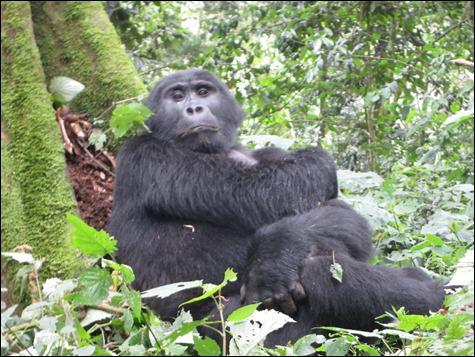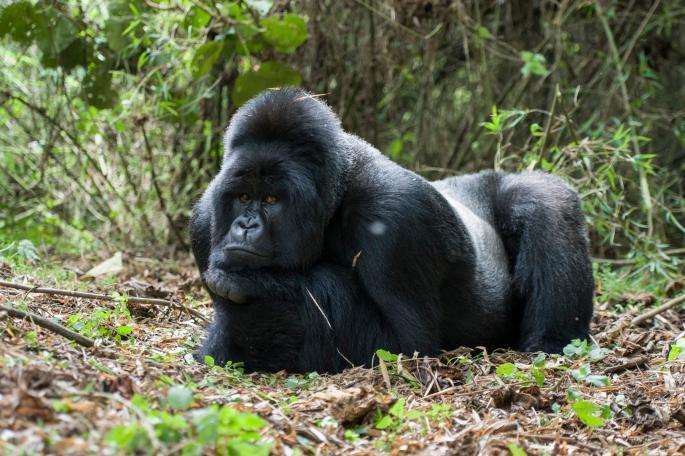The first image is the image on the left, the second image is the image on the right. Considering the images on both sides, is "One image shows a forward-gazing gorilla reclining on its side with its head to the right, and the other image features a rightward-facing gorilla with its head in profile." valid? Answer yes or no. No. The first image is the image on the left, the second image is the image on the right. Analyze the images presented: Is the assertion "One ape is laying on its stomach." valid? Answer yes or no. Yes. 